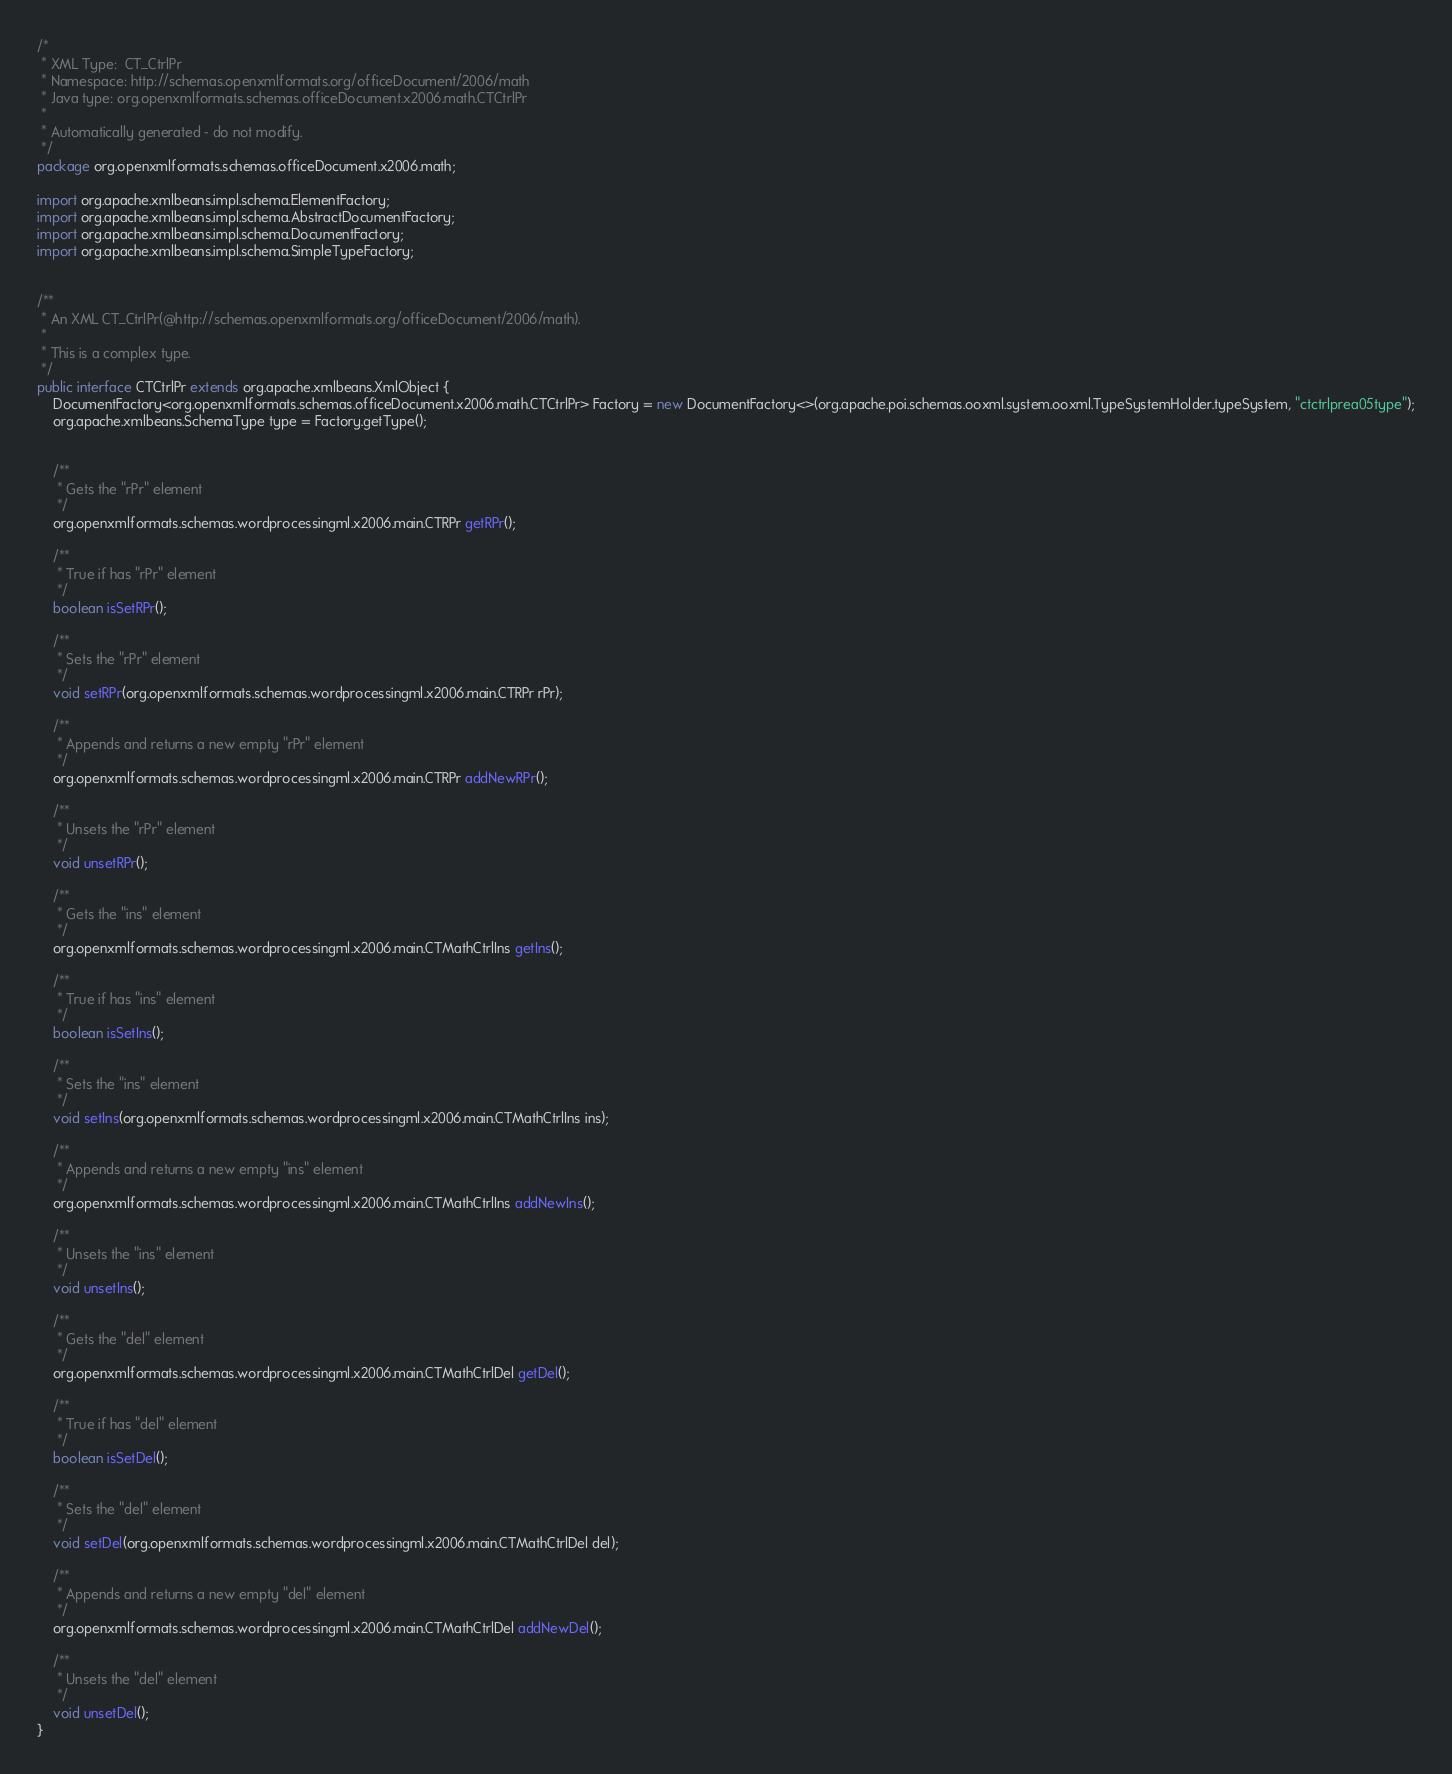Convert code to text. <code><loc_0><loc_0><loc_500><loc_500><_Java_>/*
 * XML Type:  CT_CtrlPr
 * Namespace: http://schemas.openxmlformats.org/officeDocument/2006/math
 * Java type: org.openxmlformats.schemas.officeDocument.x2006.math.CTCtrlPr
 *
 * Automatically generated - do not modify.
 */
package org.openxmlformats.schemas.officeDocument.x2006.math;

import org.apache.xmlbeans.impl.schema.ElementFactory;
import org.apache.xmlbeans.impl.schema.AbstractDocumentFactory;
import org.apache.xmlbeans.impl.schema.DocumentFactory;
import org.apache.xmlbeans.impl.schema.SimpleTypeFactory;


/**
 * An XML CT_CtrlPr(@http://schemas.openxmlformats.org/officeDocument/2006/math).
 *
 * This is a complex type.
 */
public interface CTCtrlPr extends org.apache.xmlbeans.XmlObject {
    DocumentFactory<org.openxmlformats.schemas.officeDocument.x2006.math.CTCtrlPr> Factory = new DocumentFactory<>(org.apache.poi.schemas.ooxml.system.ooxml.TypeSystemHolder.typeSystem, "ctctrlprea05type");
    org.apache.xmlbeans.SchemaType type = Factory.getType();


    /**
     * Gets the "rPr" element
     */
    org.openxmlformats.schemas.wordprocessingml.x2006.main.CTRPr getRPr();

    /**
     * True if has "rPr" element
     */
    boolean isSetRPr();

    /**
     * Sets the "rPr" element
     */
    void setRPr(org.openxmlformats.schemas.wordprocessingml.x2006.main.CTRPr rPr);

    /**
     * Appends and returns a new empty "rPr" element
     */
    org.openxmlformats.schemas.wordprocessingml.x2006.main.CTRPr addNewRPr();

    /**
     * Unsets the "rPr" element
     */
    void unsetRPr();

    /**
     * Gets the "ins" element
     */
    org.openxmlformats.schemas.wordprocessingml.x2006.main.CTMathCtrlIns getIns();

    /**
     * True if has "ins" element
     */
    boolean isSetIns();

    /**
     * Sets the "ins" element
     */
    void setIns(org.openxmlformats.schemas.wordprocessingml.x2006.main.CTMathCtrlIns ins);

    /**
     * Appends and returns a new empty "ins" element
     */
    org.openxmlformats.schemas.wordprocessingml.x2006.main.CTMathCtrlIns addNewIns();

    /**
     * Unsets the "ins" element
     */
    void unsetIns();

    /**
     * Gets the "del" element
     */
    org.openxmlformats.schemas.wordprocessingml.x2006.main.CTMathCtrlDel getDel();

    /**
     * True if has "del" element
     */
    boolean isSetDel();

    /**
     * Sets the "del" element
     */
    void setDel(org.openxmlformats.schemas.wordprocessingml.x2006.main.CTMathCtrlDel del);

    /**
     * Appends and returns a new empty "del" element
     */
    org.openxmlformats.schemas.wordprocessingml.x2006.main.CTMathCtrlDel addNewDel();

    /**
     * Unsets the "del" element
     */
    void unsetDel();
}
</code> 